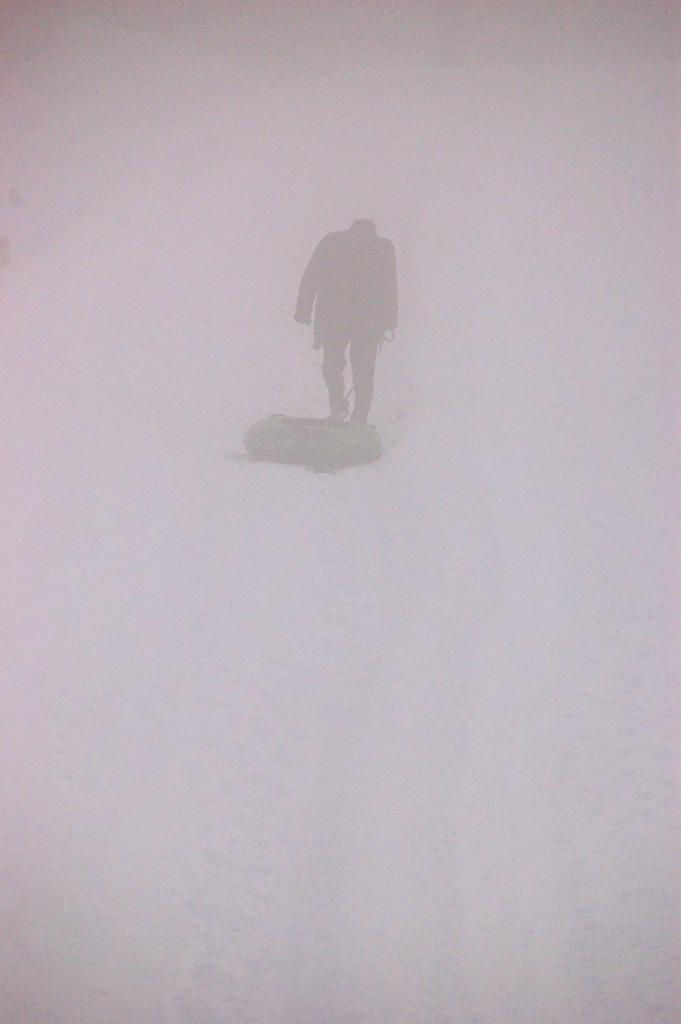What is the main subject of the image? There is a person standing in the image. What can be seen in the background of the image? There is snow visible in the background of the image. What type of nerve can be seen in the image? There is no nerve visible in the image; it features a person standing in the snow. Is there a sack of potatoes in the image? There is no sack of potatoes present in the image. 